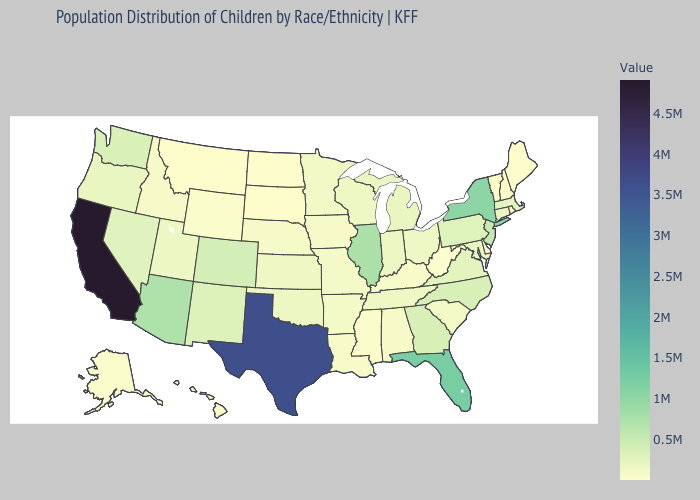Among the states that border Louisiana , which have the highest value?
Be succinct. Texas. Does New Mexico have a lower value than California?
Keep it brief. Yes. Among the states that border North Dakota , which have the highest value?
Answer briefly. Minnesota. Does New York have the highest value in the USA?
Be succinct. No. Does Vermont have the lowest value in the USA?
Concise answer only. Yes. Among the states that border Mississippi , does Tennessee have the highest value?
Write a very short answer. Yes. Does Colorado have the lowest value in the USA?
Be succinct. No. Among the states that border Massachusetts , which have the lowest value?
Be succinct. Vermont. Does Tennessee have a lower value than Arizona?
Keep it brief. Yes. 